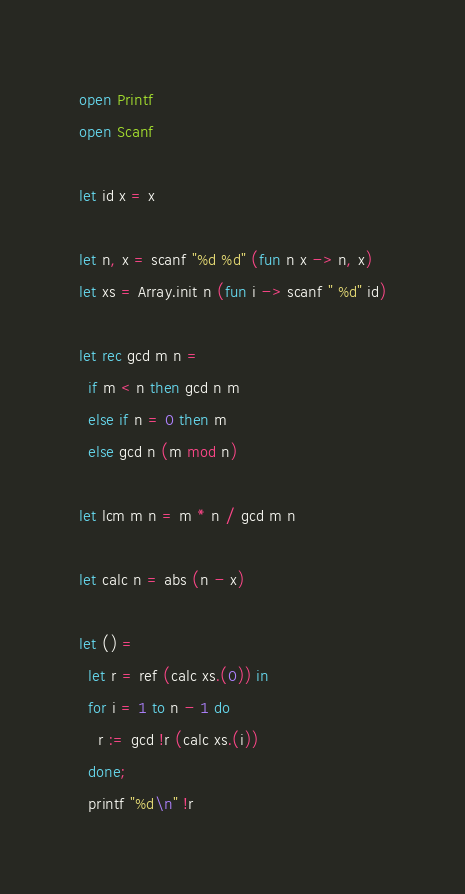<code> <loc_0><loc_0><loc_500><loc_500><_OCaml_>open Printf
open Scanf

let id x = x

let n, x = scanf "%d %d" (fun n x -> n, x)
let xs = Array.init n (fun i -> scanf " %d" id)

let rec gcd m n =
  if m < n then gcd n m
  else if n = 0 then m
  else gcd n (m mod n)

let lcm m n = m * n / gcd m n

let calc n = abs (n - x)

let () =
  let r = ref (calc xs.(0)) in
  for i = 1 to n - 1 do
    r := gcd !r (calc xs.(i))
  done;
  printf "%d\n" !r
</code> 